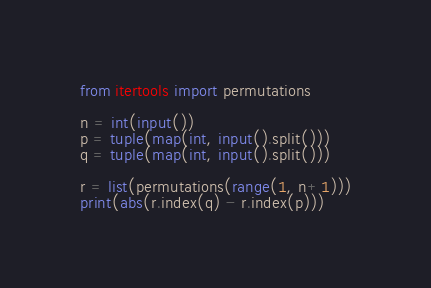Convert code to text. <code><loc_0><loc_0><loc_500><loc_500><_Python_>from itertools import permutations

n = int(input())
p = tuple(map(int, input().split()))
q = tuple(map(int, input().split()))

r = list(permutations(range(1, n+1)))
print(abs(r.index(q) - r.index(p)))</code> 